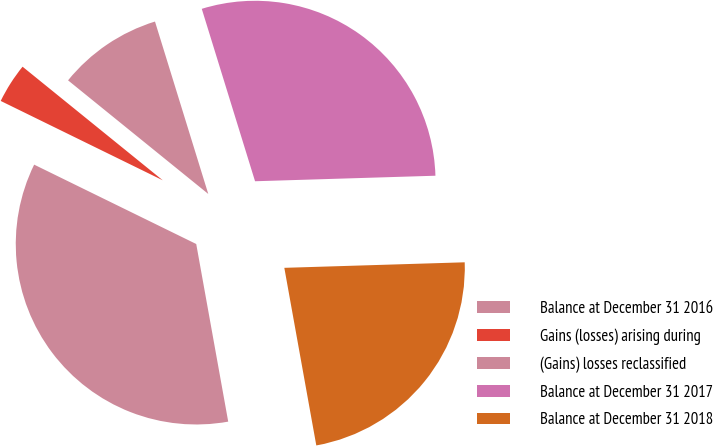Convert chart to OTSL. <chart><loc_0><loc_0><loc_500><loc_500><pie_chart><fcel>Balance at December 31 2016<fcel>Gains (losses) arising during<fcel>(Gains) losses reclassified<fcel>Balance at December 31 2017<fcel>Balance at December 31 2018<nl><fcel>35.08%<fcel>3.59%<fcel>9.39%<fcel>29.28%<fcel>22.65%<nl></chart> 